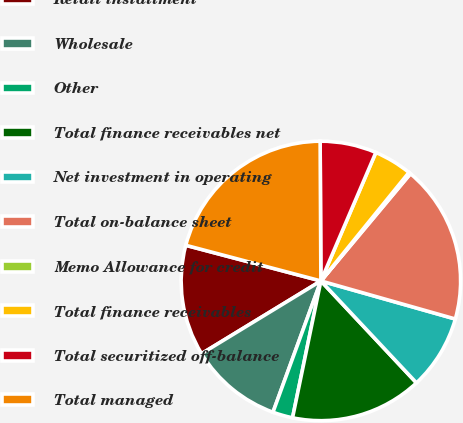<chart> <loc_0><loc_0><loc_500><loc_500><pie_chart><fcel>Retail installment<fcel>Wholesale<fcel>Other<fcel>Total finance receivables net<fcel>Net investment in operating<fcel>Total on-balance sheet<fcel>Memo Allowance for credit<fcel>Total finance receivables<fcel>Total securitized off-balance<fcel>Total managed<nl><fcel>12.82%<fcel>10.72%<fcel>2.32%<fcel>15.24%<fcel>8.62%<fcel>18.32%<fcel>0.22%<fcel>4.42%<fcel>6.52%<fcel>20.81%<nl></chart> 